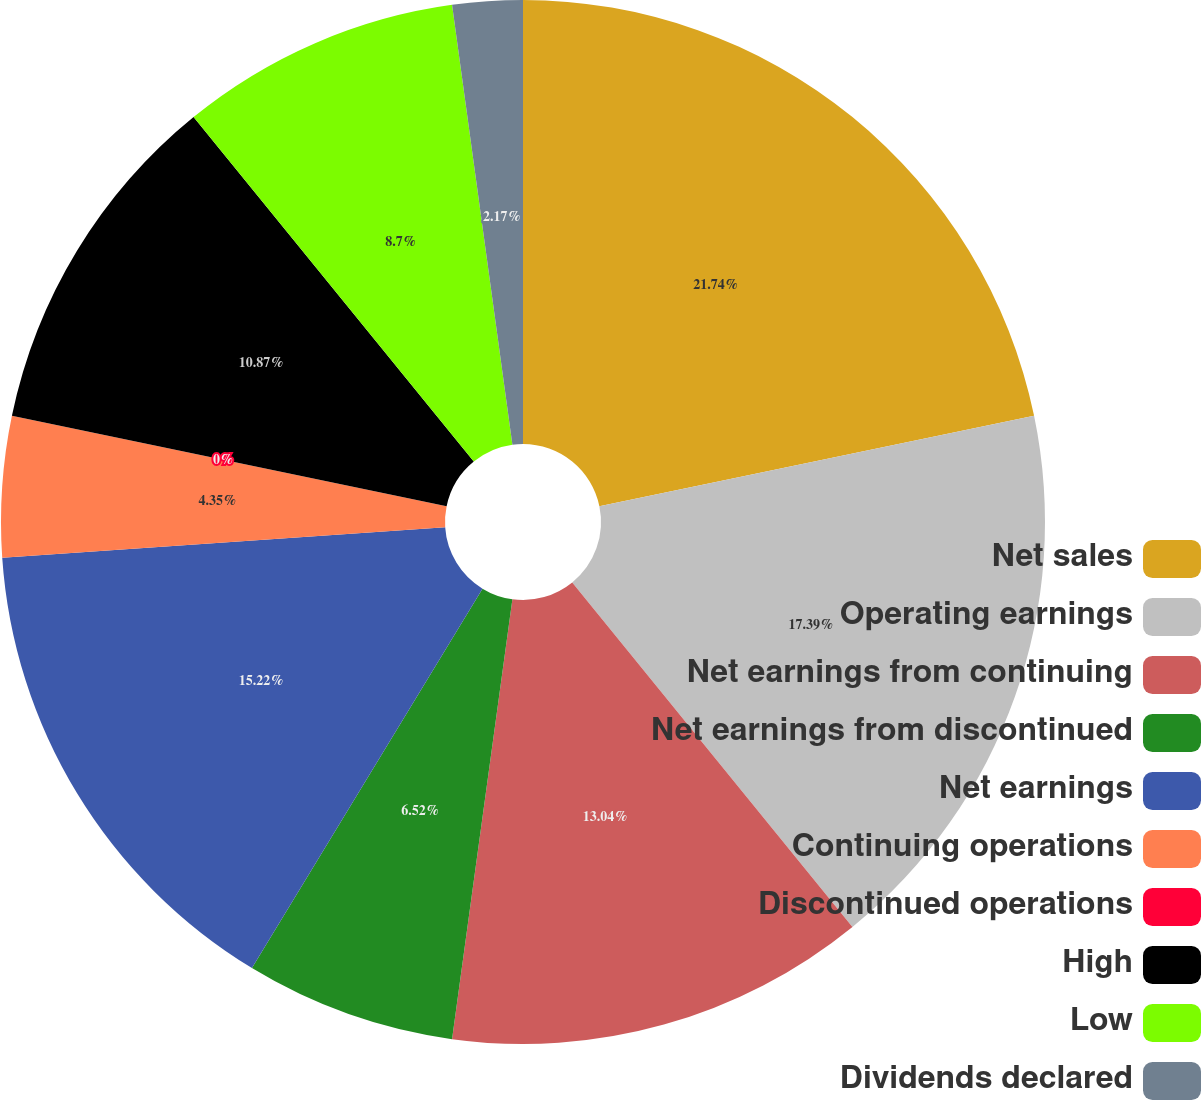<chart> <loc_0><loc_0><loc_500><loc_500><pie_chart><fcel>Net sales<fcel>Operating earnings<fcel>Net earnings from continuing<fcel>Net earnings from discontinued<fcel>Net earnings<fcel>Continuing operations<fcel>Discontinued operations<fcel>High<fcel>Low<fcel>Dividends declared<nl><fcel>21.74%<fcel>17.39%<fcel>13.04%<fcel>6.52%<fcel>15.22%<fcel>4.35%<fcel>0.0%<fcel>10.87%<fcel>8.7%<fcel>2.17%<nl></chart> 